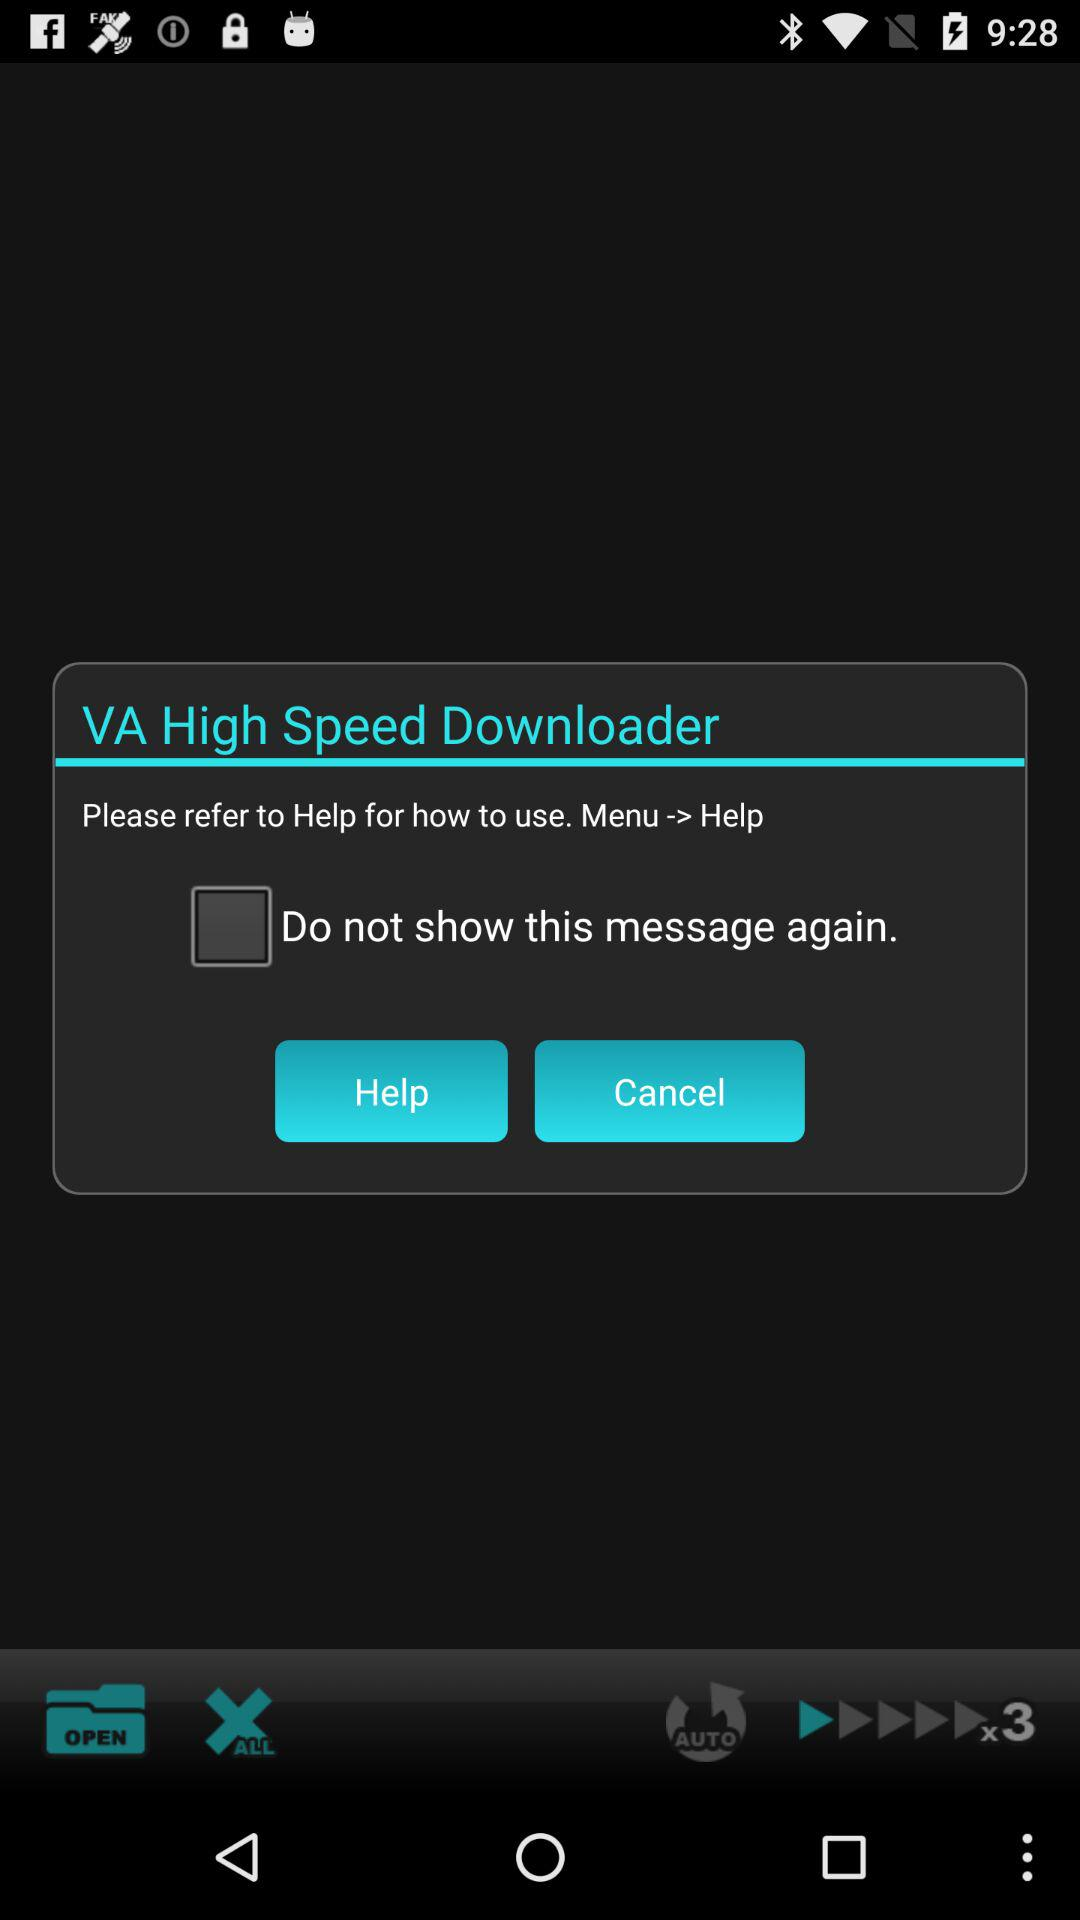When was "VA High Speed Downloader" copyrighted?
When the provided information is insufficient, respond with <no answer>. <no answer> 